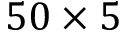Convert formula to latex. <formula><loc_0><loc_0><loc_500><loc_500>5 0 \times 5</formula> 